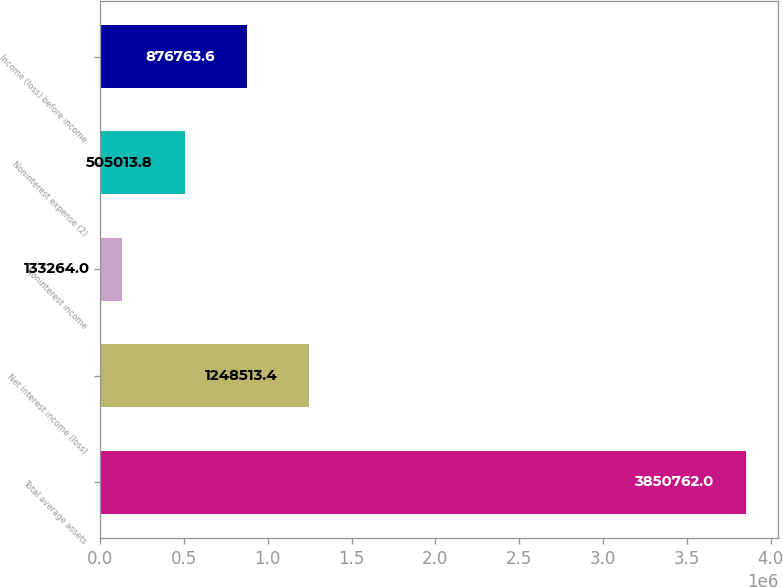<chart> <loc_0><loc_0><loc_500><loc_500><bar_chart><fcel>Total average assets<fcel>Net interest income (loss)<fcel>Noninterest income<fcel>Noninterest expense (2)<fcel>Income (loss) before income<nl><fcel>3.85076e+06<fcel>1.24851e+06<fcel>133264<fcel>505014<fcel>876764<nl></chart> 